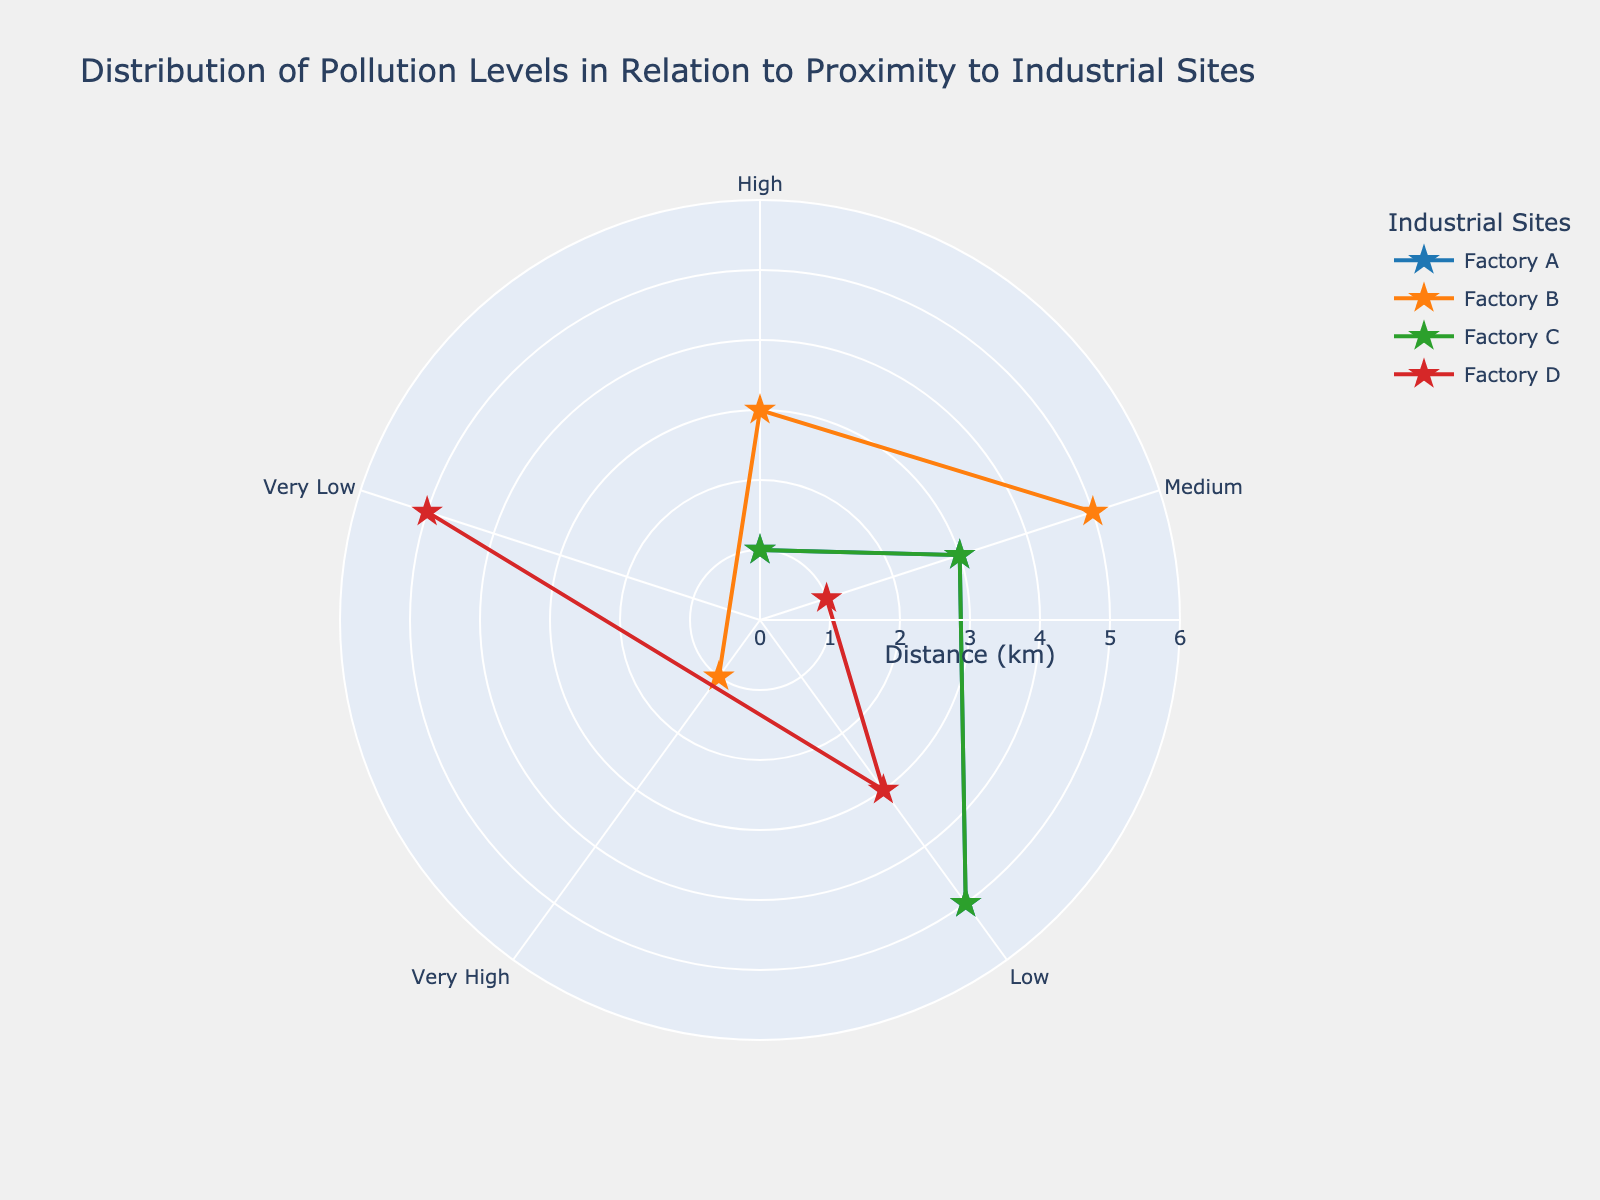What is the title of the chart? The title of the chart is displayed at the top and reads "Distribution of Pollution Levels in Relation to Proximity to Industrial Sites".
Answer: Distribution of Pollution Levels in Relation to Proximity to Industrial Sites Which factory has the highest pollution level at 1 km distance? By examining the markers at 1 km distance, Factory B shows a "Very High" pollution level.
Answer: Factory B How does the pollution level change with distance from Factory D? For Factory D, the pollution level decreases as the distance increases: at 1 km it's "Medium", at 3 km it's "Low", and at 5 km it's "Very Low".
Answer: Decreases Which factory has the most consistent pollution levels across the distances? Factory C maintains a consistent pattern with "High" at 1 km, "Medium" at 3 km, and "Low" at 5 km, similarly to Factory A but with a less steep gradient.
Answer: Factory C Which factories have a "High" pollution level at any distance? Factories A, B, and C have a "High" pollution level at some distance, as seen from their markers.
Answer: Factories A, B, and C How many pollution levels are represented in the chart? There are five pollution levels represented: Very High, High, Medium, Low, and Very Low, as noted in the angular axis.
Answer: Five Between Factories A and D, which one has lower pollution levels overall? By comparing the pollution levels at all distances, Factory D generally maintains lower pollution levels ("Medium" to "Very Low") compared to Factory A ("High" to "Low").
Answer: Factory D Which factory has the lowest pollution level at 1 km distance? By checking the markers at 1 km, Factory D has the lowest pollution level with a "Medium" level.
Answer: Factory D Do any factories have the same pollution level at 5 km distance? Factories A and C both have a "Low" pollution level at 5 km distance, confirming equal pollution levels at that distance.
Answer: Factories A and C What can be inferred about the relation between distance and pollution level from the chart? Generally, pollution levels tend to decrease as the distance from the factories increases, as shown by the markers moving from higher to lower pollution levels with increasing distance.
Answer: Pollution levels decrease with distance 